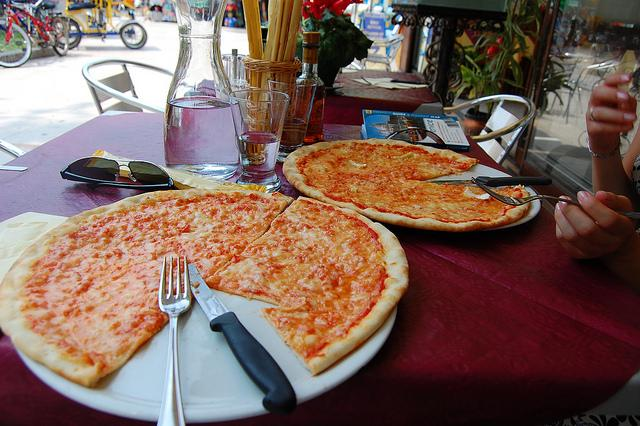What color is the vase in the middle of the table surrounded by pizzas? clear 